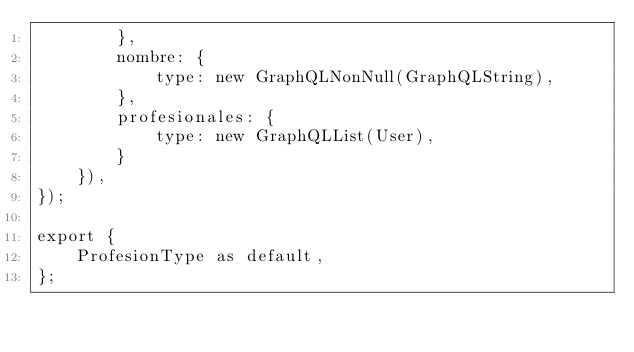<code> <loc_0><loc_0><loc_500><loc_500><_JavaScript_>        },
        nombre: {
            type: new GraphQLNonNull(GraphQLString),
        },
        profesionales: {
            type: new GraphQLList(User),
        }
    }),
});

export {
    ProfesionType as default,
};</code> 